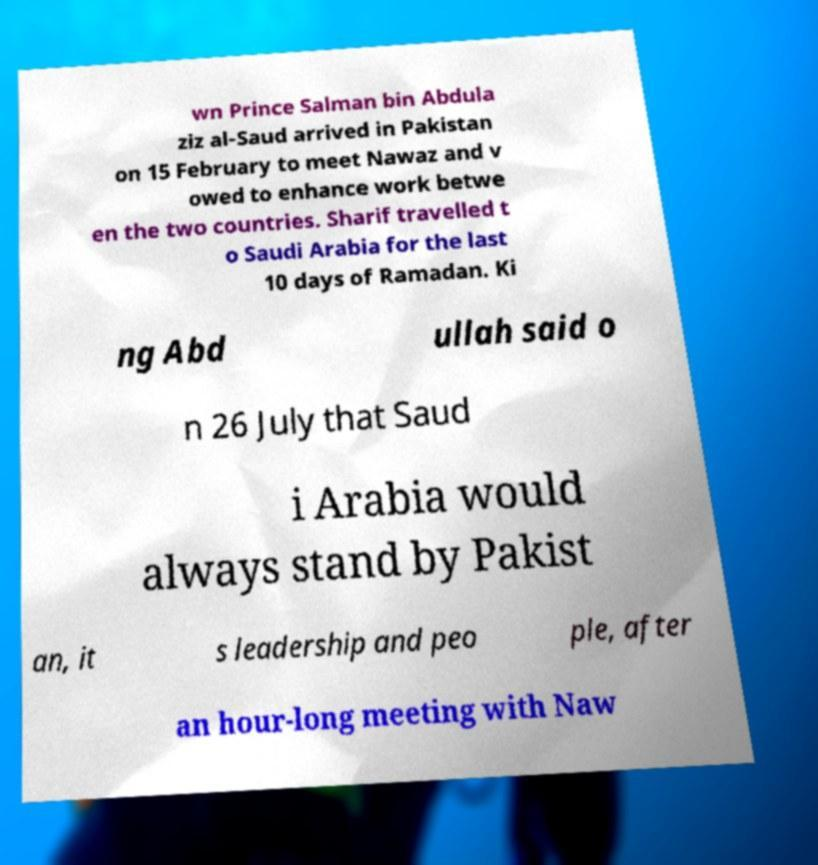Could you assist in decoding the text presented in this image and type it out clearly? wn Prince Salman bin Abdula ziz al-Saud arrived in Pakistan on 15 February to meet Nawaz and v owed to enhance work betwe en the two countries. Sharif travelled t o Saudi Arabia for the last 10 days of Ramadan. Ki ng Abd ullah said o n 26 July that Saud i Arabia would always stand by Pakist an, it s leadership and peo ple, after an hour-long meeting with Naw 